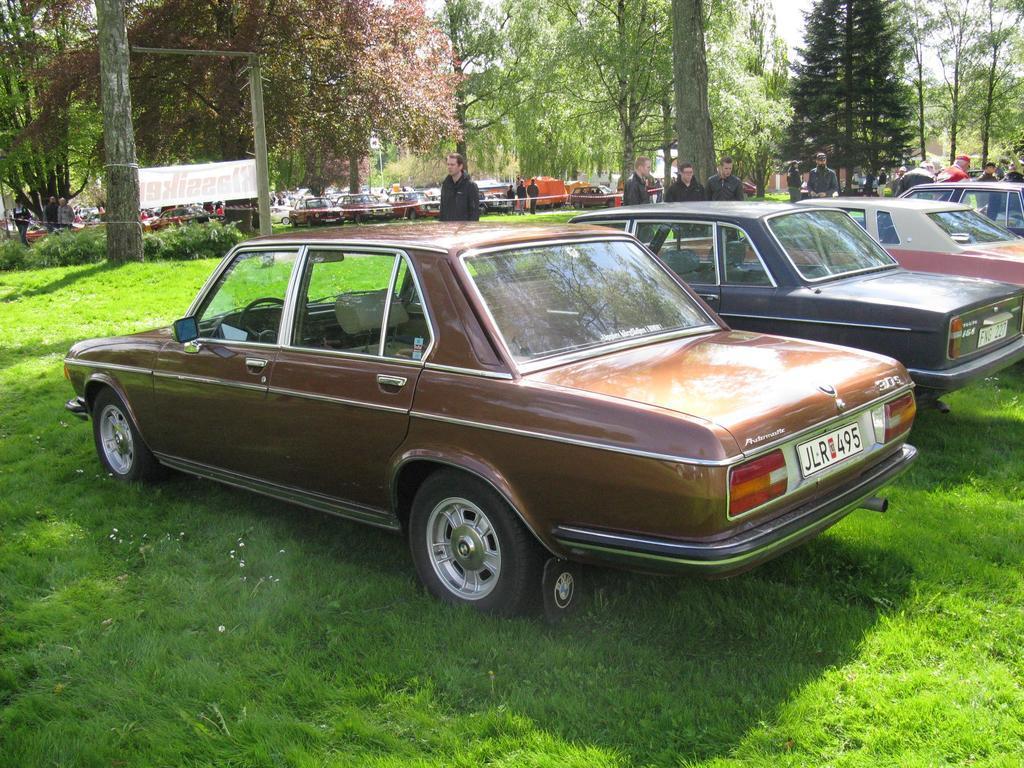Can you describe this image briefly? In this image we can see many cars placed in rows. In the background there are trees, persons, advertisement, pole, sky and grass. 